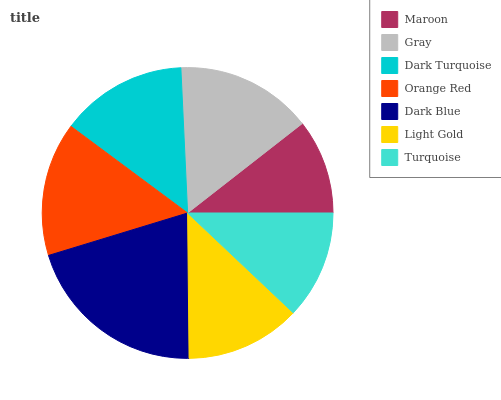Is Maroon the minimum?
Answer yes or no. Yes. Is Dark Blue the maximum?
Answer yes or no. Yes. Is Gray the minimum?
Answer yes or no. No. Is Gray the maximum?
Answer yes or no. No. Is Gray greater than Maroon?
Answer yes or no. Yes. Is Maroon less than Gray?
Answer yes or no. Yes. Is Maroon greater than Gray?
Answer yes or no. No. Is Gray less than Maroon?
Answer yes or no. No. Is Dark Turquoise the high median?
Answer yes or no. Yes. Is Dark Turquoise the low median?
Answer yes or no. Yes. Is Light Gold the high median?
Answer yes or no. No. Is Dark Blue the low median?
Answer yes or no. No. 